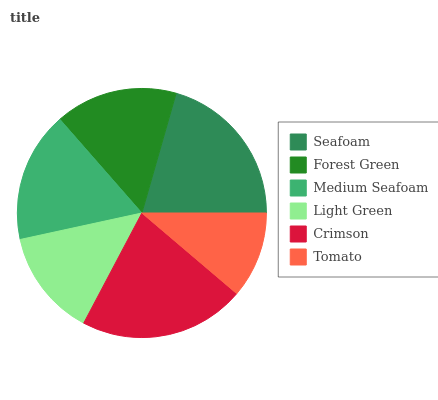Is Tomato the minimum?
Answer yes or no. Yes. Is Crimson the maximum?
Answer yes or no. Yes. Is Forest Green the minimum?
Answer yes or no. No. Is Forest Green the maximum?
Answer yes or no. No. Is Seafoam greater than Forest Green?
Answer yes or no. Yes. Is Forest Green less than Seafoam?
Answer yes or no. Yes. Is Forest Green greater than Seafoam?
Answer yes or no. No. Is Seafoam less than Forest Green?
Answer yes or no. No. Is Medium Seafoam the high median?
Answer yes or no. Yes. Is Forest Green the low median?
Answer yes or no. Yes. Is Forest Green the high median?
Answer yes or no. No. Is Tomato the low median?
Answer yes or no. No. 